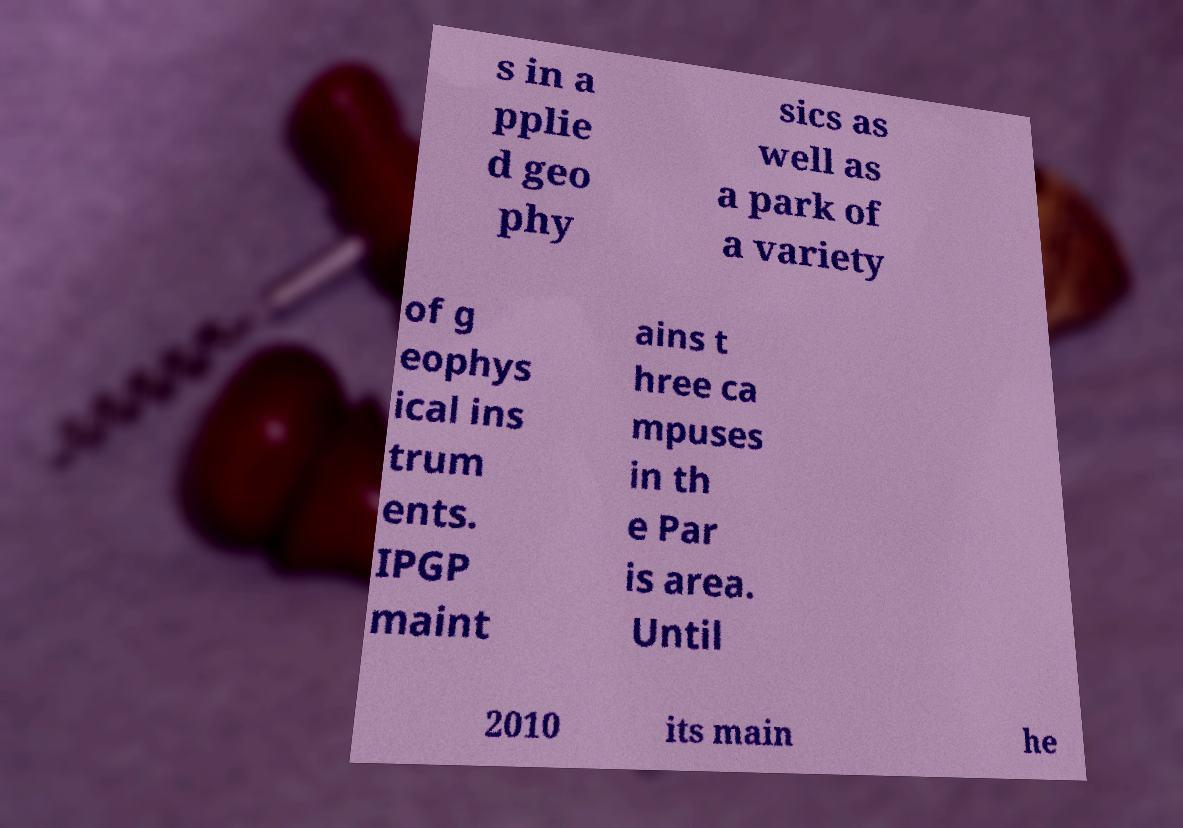For documentation purposes, I need the text within this image transcribed. Could you provide that? s in a pplie d geo phy sics as well as a park of a variety of g eophys ical ins trum ents. IPGP maint ains t hree ca mpuses in th e Par is area. Until 2010 its main he 